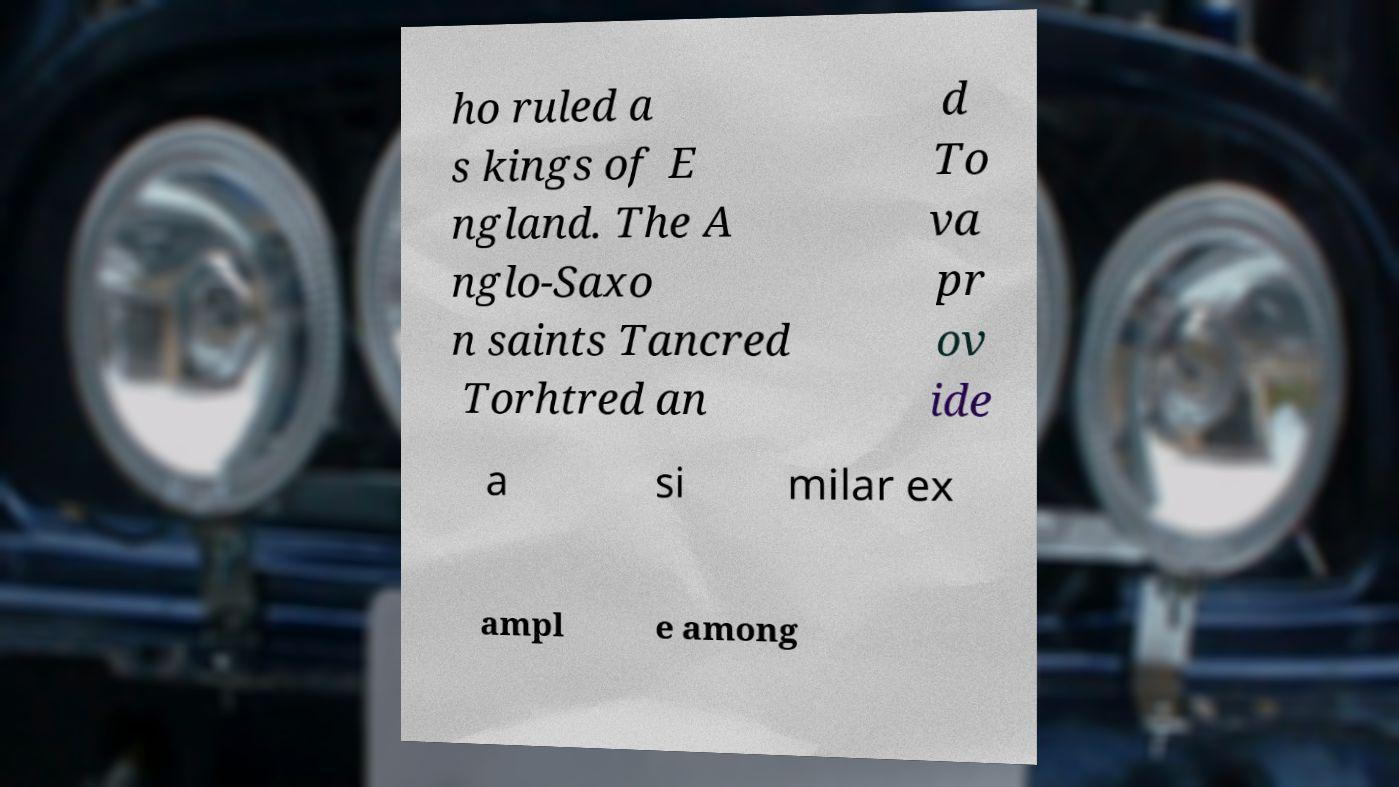Could you extract and type out the text from this image? ho ruled a s kings of E ngland. The A nglo-Saxo n saints Tancred Torhtred an d To va pr ov ide a si milar ex ampl e among 